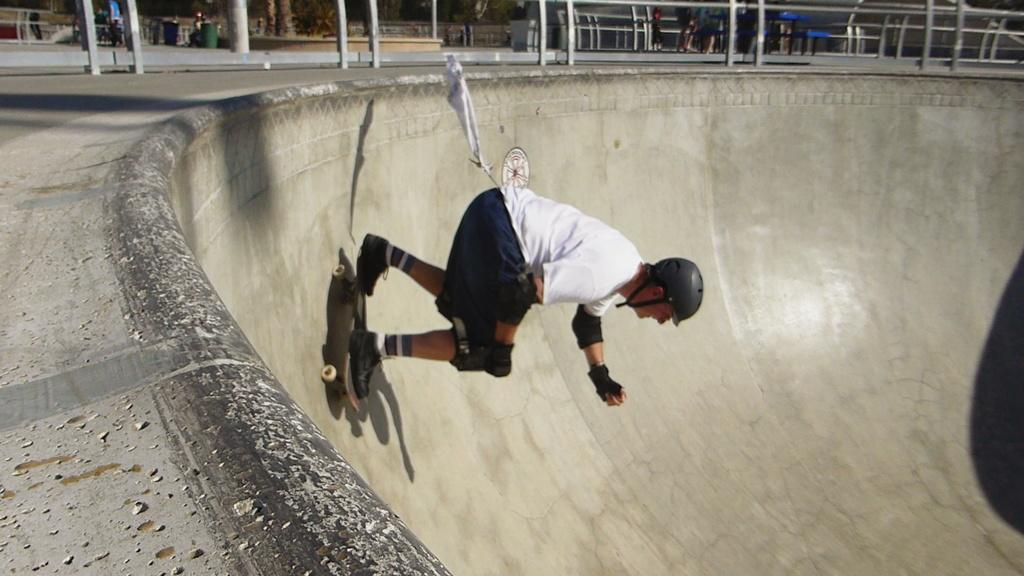Who is present in the image? There is a man in the image. What is the man holding in the image? The man is holding a skateboard. Where is the man skating in the image? The man is skating in a skating park. What can be seen around the skating park in the image? There is fencing around the skating park. What type of powder is being used by the coach in the image? There is no coach or powder present in the image. 